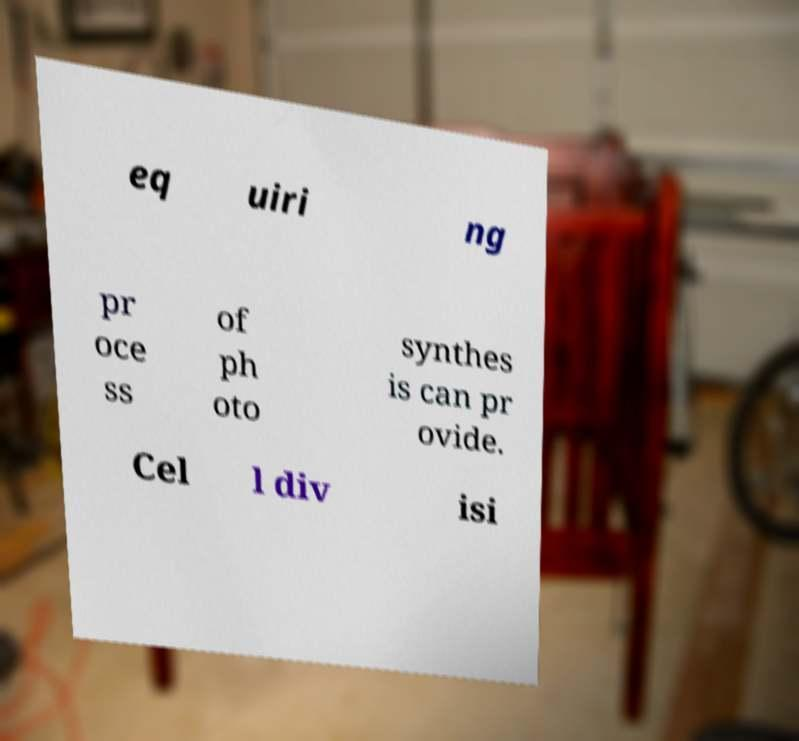Can you read and provide the text displayed in the image?This photo seems to have some interesting text. Can you extract and type it out for me? eq uiri ng pr oce ss of ph oto synthes is can pr ovide. Cel l div isi 